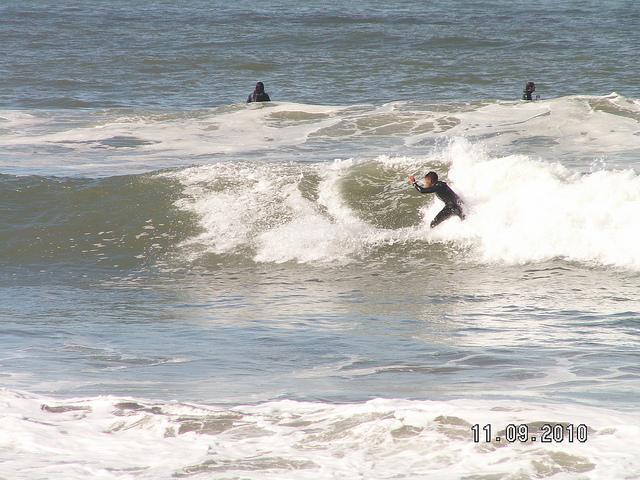How many waves are pictured?
Give a very brief answer. 3. How many people are surfing?
Give a very brief answer. 3. 